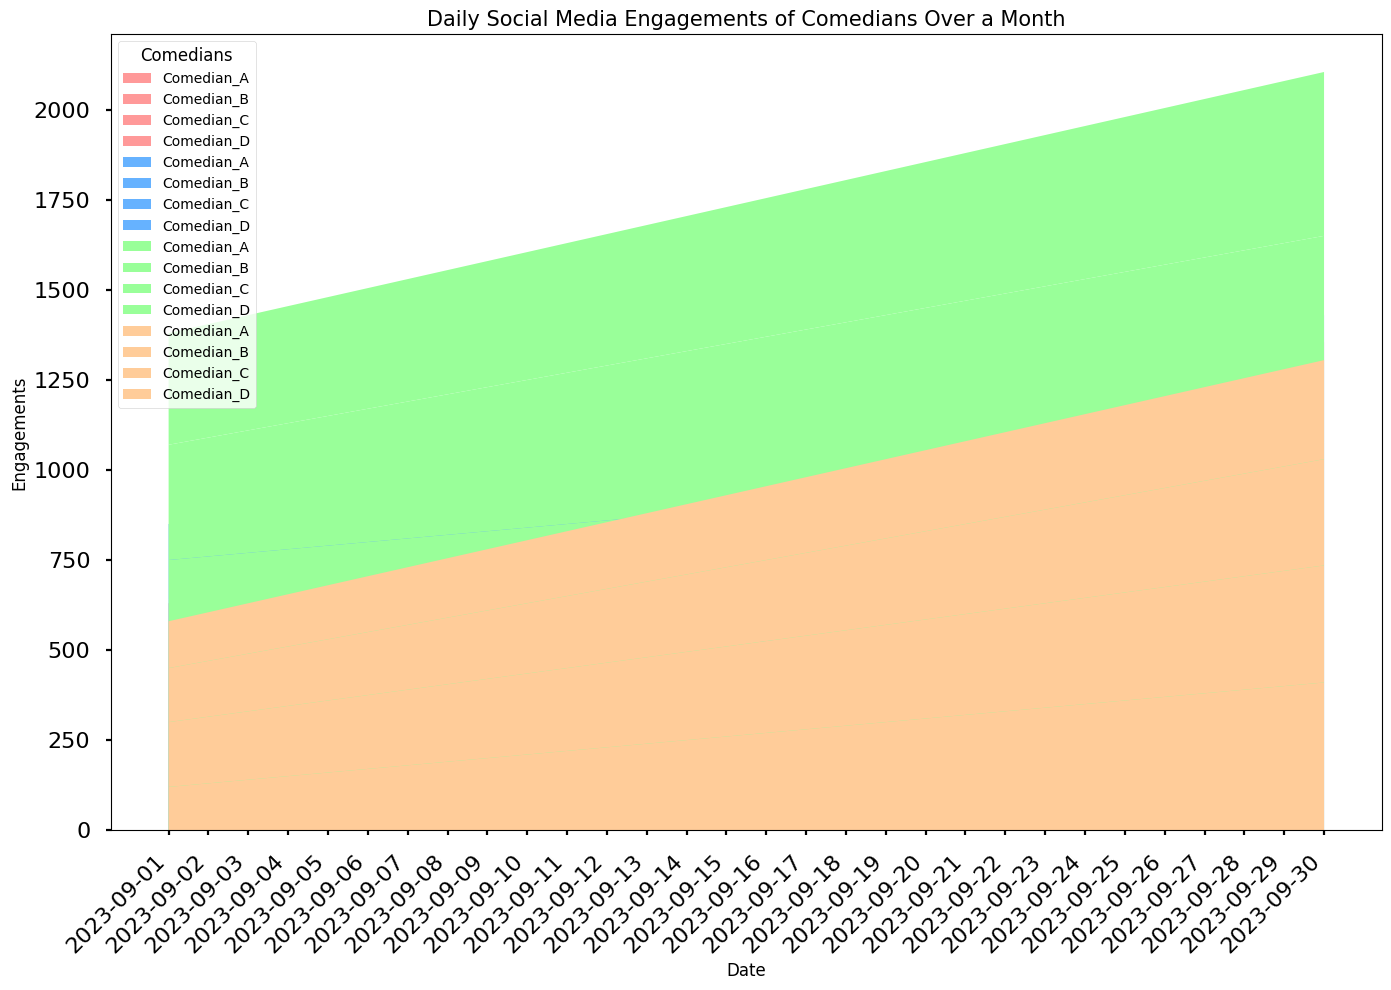Which social media platform saw the highest engagement overall? To determine this, look at which color-coded section dominates the stack plot. The green area representing Instagram appears to be the widest across the chart, indicating the highest engagement.
Answer: Instagram Which comedian had the highest engagement on Twitter by the end of the month? Look at the areas represented by different colors for the last date on the X-axis. The blue section, representing Twitter for different comedians, appears to be highest for Comedian_A.
Answer: Comedian_A How does Comedian_C's engagement on YouTube compare to Comedian_B's on the same platform by mid-month? Check the orange sections for both comedians around the middle of the graph (around September 15). Comedian_C's YouTube engagements are higher than those of Comedian_B.
Answer: Comedian_C has higher YouTube engagement On which platform and date did Comedian_D have their lowest social media engagement? Scan the area chart, focusing on the purple sections representing Comedian_D. The lowest point for these sections appears around September 1. Analyze visually for all platforms: Facebook, Twitter, Instagram, and YouTube. Comedian_D's lowest engagement is on YouTube on September 1.
Answer: YouTube on September 1 What is the difference in total Facebook engagement between Comedian_A and Comedian_B at the end of September? Calculate the area for the red sections (Facebook) representing both comedians on September 30. Comedian_A's engagement is 440 and Comedian_B's is 245. The difference is 440 - 245.
Answer: 195 Which comedian consistently had the lowest engagement across all social media platforms throughout the month? Look at the overall width of the colored sections for each comedian. The smallest combined area across all platforms belongs to Comedian_B.
Answer: Comedian_B What trends can you see in Comedian_A's Instagram engagements over the month? Focus on the green areas representing Comedian_A's Instagram engagement. The width of this area gradually increases, indicating a rising trend throughout the month.
Answer: Steady increase By how much did Comedian_D’s total engagements (sum of all platforms) increase from the start of the month to the end? Add up the engagements for Comedian_D across all platforms on September 1 and compare it to those on September 30. The initial sum is 180+210+310+130 = 830 and the final sum is 325+355+455+275 = 1410. The difference is 1410 - 830.
Answer: 580 